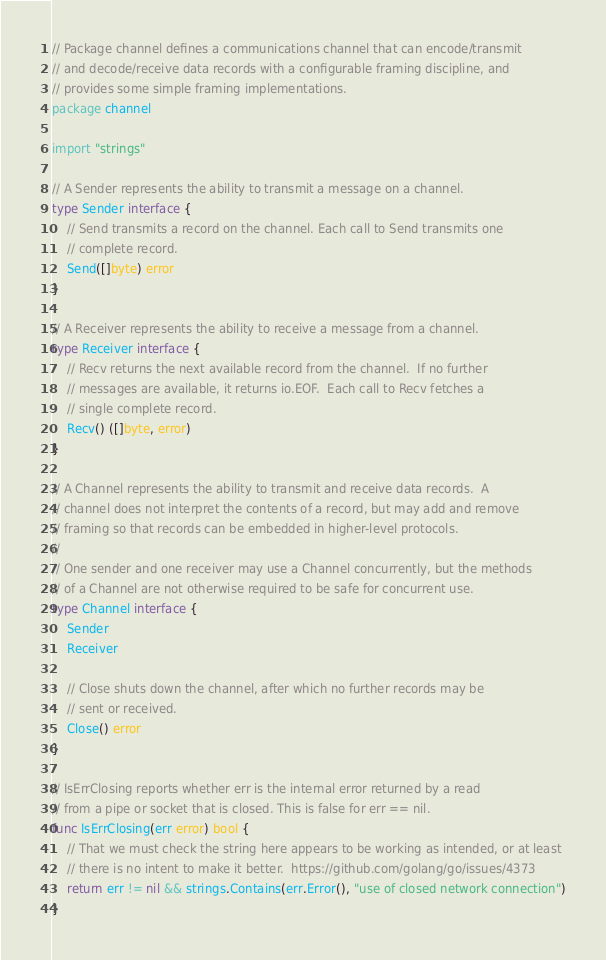Convert code to text. <code><loc_0><loc_0><loc_500><loc_500><_Go_>// Package channel defines a communications channel that can encode/transmit
// and decode/receive data records with a configurable framing discipline, and
// provides some simple framing implementations.
package channel

import "strings"

// A Sender represents the ability to transmit a message on a channel.
type Sender interface {
	// Send transmits a record on the channel. Each call to Send transmits one
	// complete record.
	Send([]byte) error
}

// A Receiver represents the ability to receive a message from a channel.
type Receiver interface {
	// Recv returns the next available record from the channel.  If no further
	// messages are available, it returns io.EOF.  Each call to Recv fetches a
	// single complete record.
	Recv() ([]byte, error)
}

// A Channel represents the ability to transmit and receive data records.  A
// channel does not interpret the contents of a record, but may add and remove
// framing so that records can be embedded in higher-level protocols.
//
// One sender and one receiver may use a Channel concurrently, but the methods
// of a Channel are not otherwise required to be safe for concurrent use.
type Channel interface {
	Sender
	Receiver

	// Close shuts down the channel, after which no further records may be
	// sent or received.
	Close() error
}

// IsErrClosing reports whether err is the internal error returned by a read
// from a pipe or socket that is closed. This is false for err == nil.
func IsErrClosing(err error) bool {
	// That we must check the string here appears to be working as intended, or at least
	// there is no intent to make it better.  https://github.com/golang/go/issues/4373
	return err != nil && strings.Contains(err.Error(), "use of closed network connection")
}
</code> 